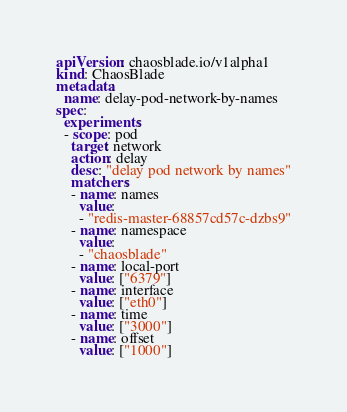Convert code to text. <code><loc_0><loc_0><loc_500><loc_500><_YAML_>apiVersion: chaosblade.io/v1alpha1
kind: ChaosBlade
metadata:
  name: delay-pod-network-by-names
spec:
  experiments:
  - scope: pod
    target: network
    action: delay
    desc: "delay pod network by names"
    matchers:
    - name: names
      value:
      - "redis-master-68857cd57c-dzbs9"
    - name: namespace
      value:
      - "chaosblade"
    - name: local-port
      value: ["6379"]
    - name: interface
      value: ["eth0"]
    - name: time
      value: ["3000"]
    - name: offset
      value: ["1000"]</code> 